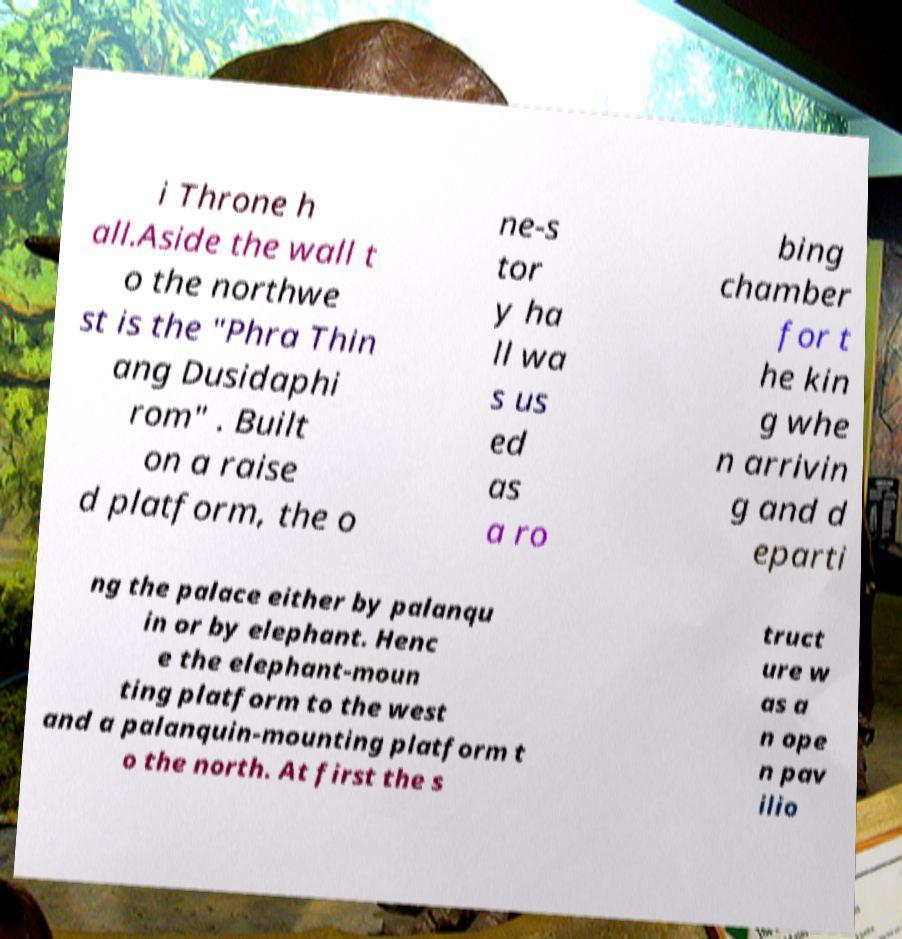What messages or text are displayed in this image? I need them in a readable, typed format. i Throne h all.Aside the wall t o the northwe st is the "Phra Thin ang Dusidaphi rom" . Built on a raise d platform, the o ne-s tor y ha ll wa s us ed as a ro bing chamber for t he kin g whe n arrivin g and d eparti ng the palace either by palanqu in or by elephant. Henc e the elephant-moun ting platform to the west and a palanquin-mounting platform t o the north. At first the s truct ure w as a n ope n pav ilio 